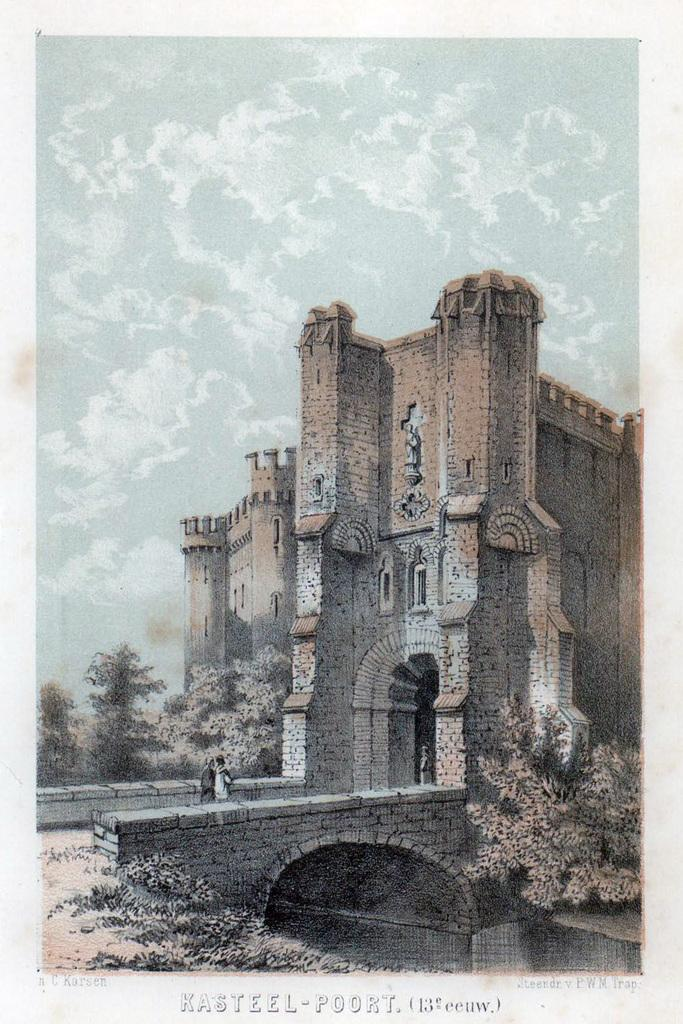What is the main subject of the image? The main subject of the image is a poster. What can be seen in the middle of the poster? There are trees, a bridge, and people in the middle of the poster. What is written or printed on the poster? There is text on the poster. What is visible at the top of the poster? The sky is visible at the top of the poster, and there are clouds in the sky. How would you describe the style of the image? The image appears to be an artistic representation. What type of cake is being served during the recess in the image? There is no recess or cake present in the image; it features a poster with various elements, including trees, a bridge, people, text, and a sky with clouds. 